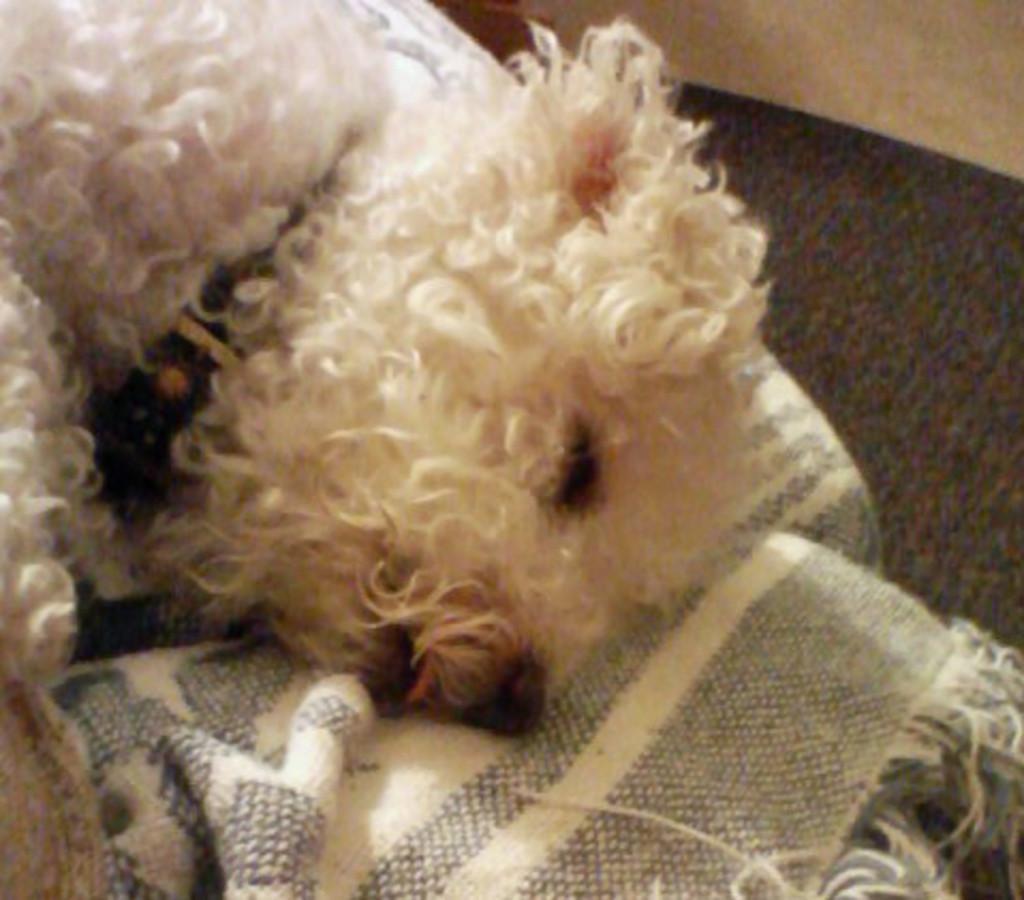Could you give a brief overview of what you see in this image? In this image there is a dog lying on the bed-sheet. 